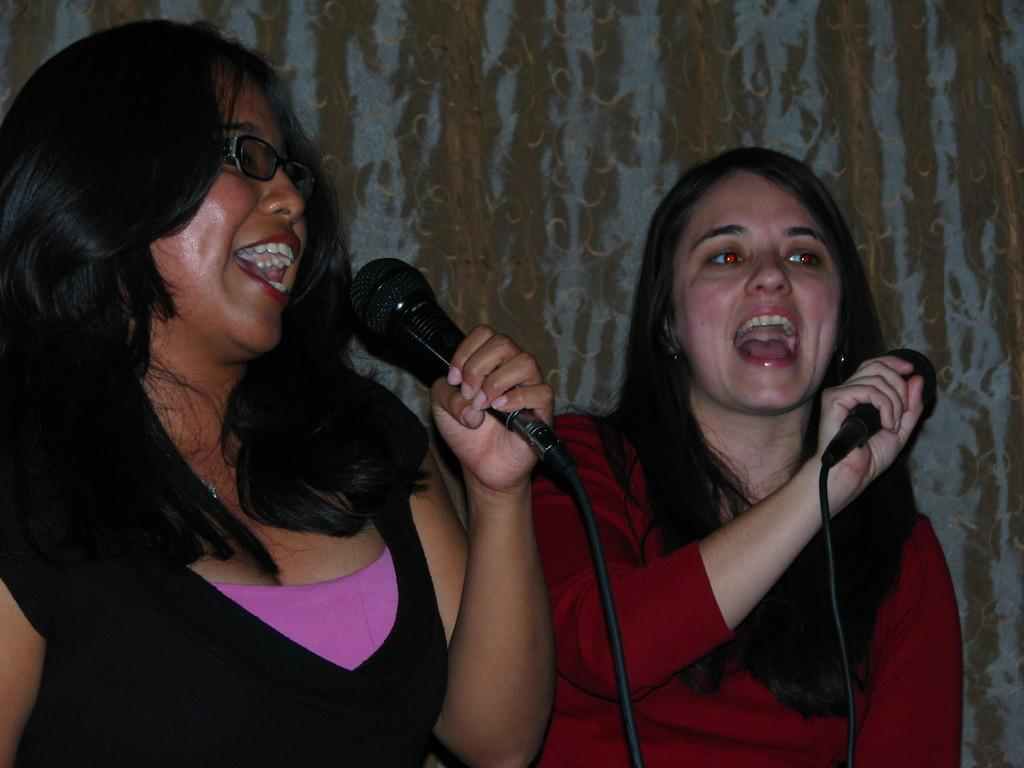How many people are in the image? There are two women in the image. What are the women holding in the image? The women are holding microphones. What activity are the women engaged in? The women are singing. What type of tiger can be seen in the image? There is no tiger present in the image. Is the prison visible in the background of the image? There is no prison present in the image. 